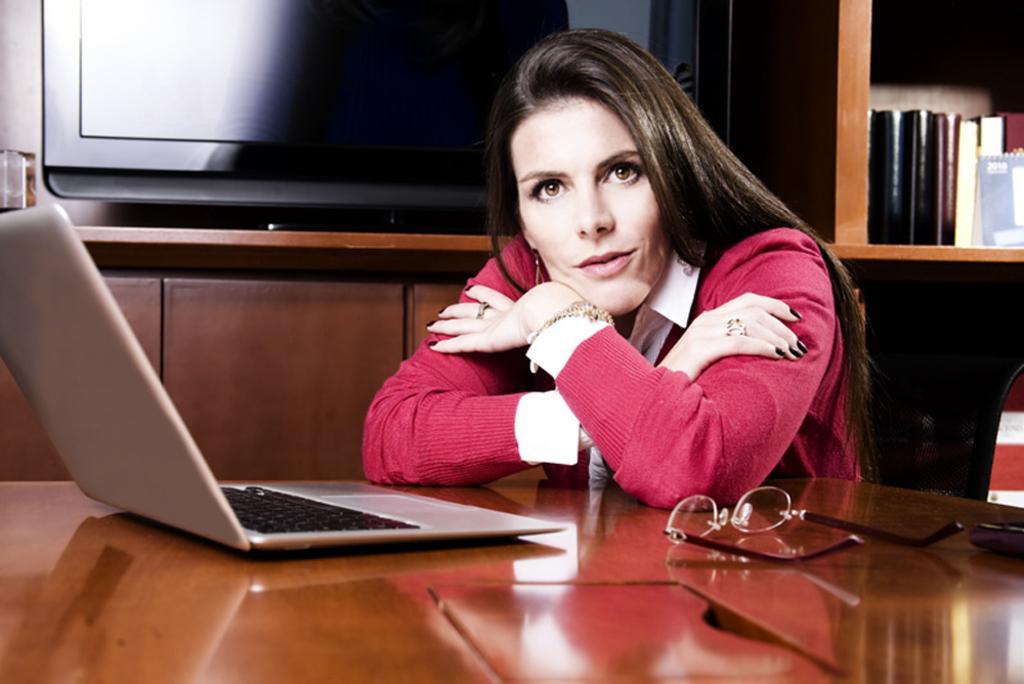How would you summarize this image in a sentence or two? In this picture we can see a woman sitting on a chair in the center. This is a wooden table where a spectacles and a laptop are kept on it. This is a television and these are books. 